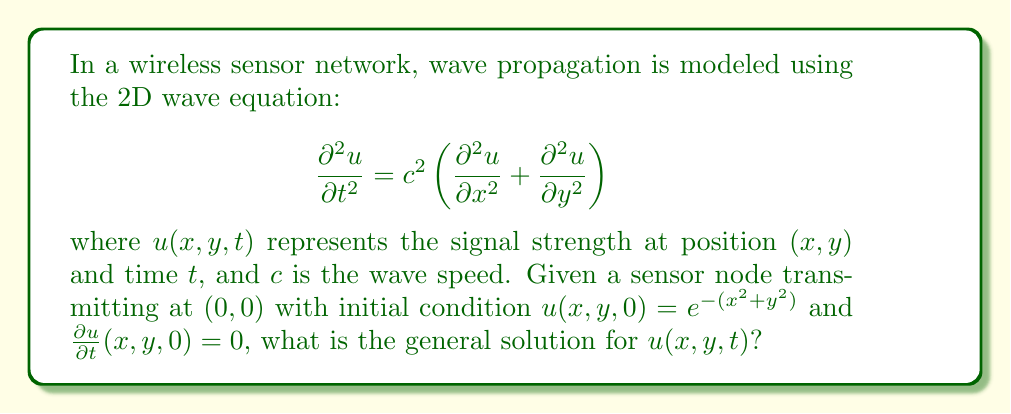Can you solve this math problem? To solve this problem, we'll follow these steps:

1) The general solution for the 2D wave equation with radial symmetry is given by d'Alembert's formula:

   $$u(r,t) = \frac{1}{2}[f(r+ct) + f(r-ct)] + \frac{1}{2ct}\int_{r-ct}^{r+ct} s g(s) ds$$

   where $r = \sqrt{x^2 + y^2}$, $f(r)$ is the initial displacement, and $g(r)$ is the initial velocity.

2) In our case, $f(r) = e^{-r^2}$ and $g(r) = 0$.

3) Substituting these into d'Alembert's formula:

   $$u(r,t) = \frac{1}{2}[e^{-(r+ct)^2} + e^{-(r-ct)^2}]$$

4) To express this in terms of $x$ and $y$, we substitute $r = \sqrt{x^2 + y^2}$:

   $$u(x,y,t) = \frac{1}{2}[e^{-(\sqrt{x^2+y^2}+ct)^2} + e^{-(\sqrt{x^2+y^2}-ct)^2}]$$

This is the general solution for the given initial conditions.
Answer: $$u(x,y,t) = \frac{1}{2}[e^{-(\sqrt{x^2+y^2}+ct)^2} + e^{-(\sqrt{x^2+y^2}-ct)^2}]$$ 